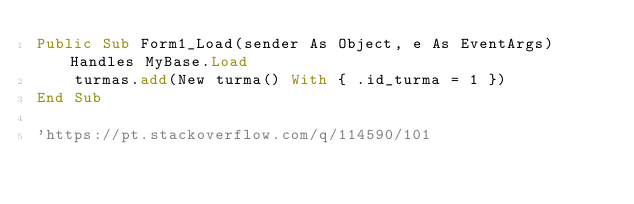<code> <loc_0><loc_0><loc_500><loc_500><_VisualBasic_>Public Sub Form1_Load(sender As Object, e As EventArgs) Handles MyBase.Load
    turmas.add(New turma() With { .id_turma = 1 })
End Sub

'https://pt.stackoverflow.com/q/114590/101
</code> 